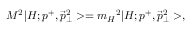Convert formula to latex. <formula><loc_0><loc_0><loc_500><loc_500>M ^ { 2 } | H ; p ^ { + } , { \vec { p } _ { \perp } } ^ { 2 } > = { m _ { H } } ^ { 2 } | H ; p ^ { + } , { \vec { p } _ { \perp } } ^ { 2 } > ,</formula> 